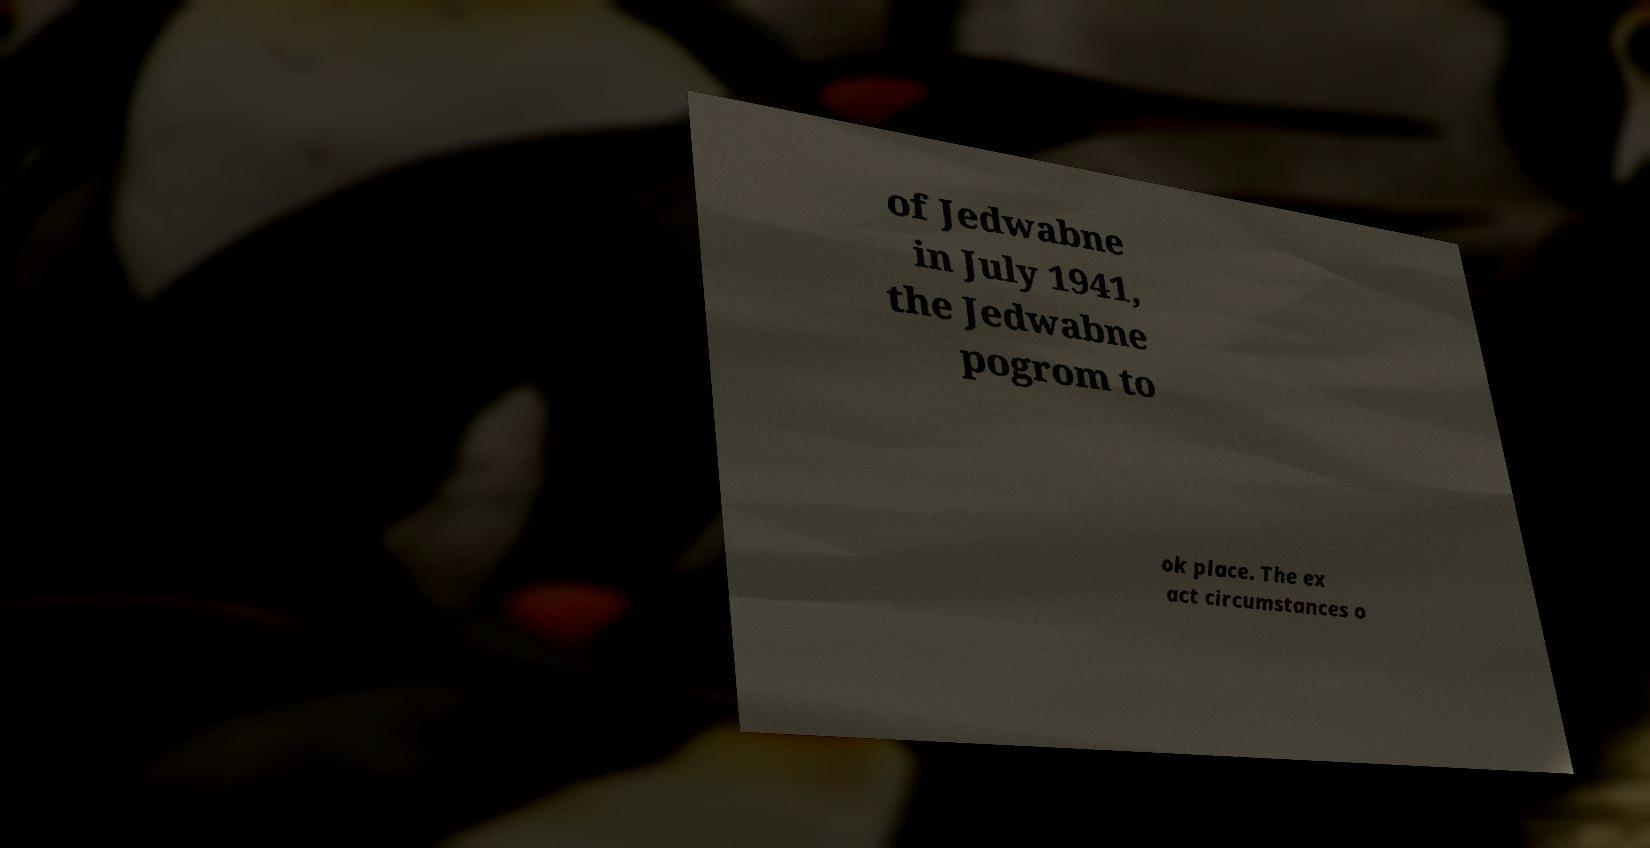Can you read and provide the text displayed in the image?This photo seems to have some interesting text. Can you extract and type it out for me? of Jedwabne in July 1941, the Jedwabne pogrom to ok place. The ex act circumstances o 